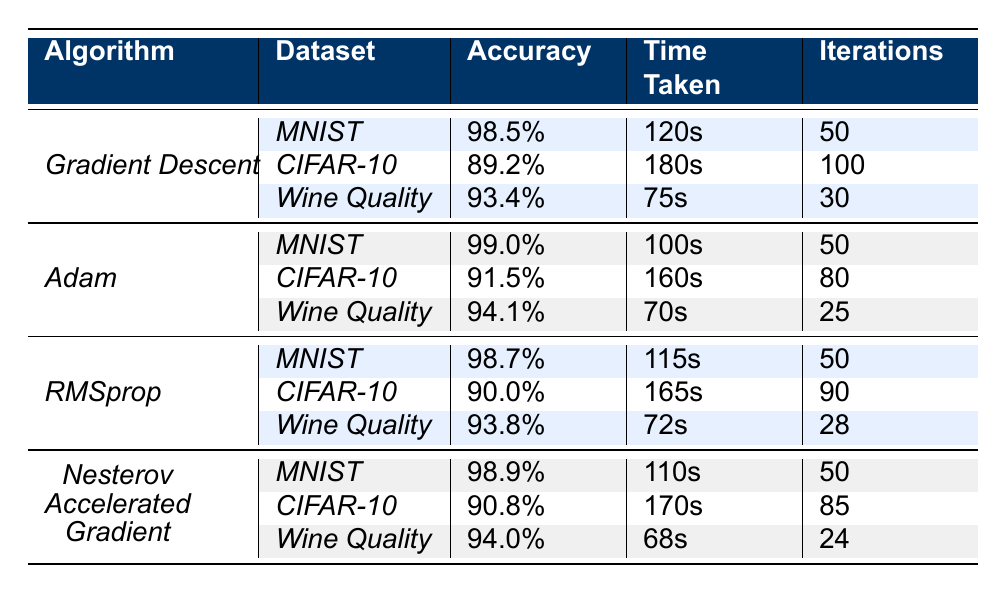What is the accuracy of the Adam algorithm on the MNIST dataset? The table shows that the accuracy of the Adam algorithm on the MNIST dataset is 99.0%.
Answer: 99.0% Which algorithm takes the least amount of time on the Wine Quality dataset? Looking at the table, the algorithm that takes the least amount of time on the Wine Quality dataset is Adam with 70 seconds.
Answer: Adam What is the difference in accuracy between Gradient Descent and RMSprop on the CIFAR-10 dataset? The accuracy of Gradient Descent on CIFAR-10 is 89.2% and RMSprop is 90.0%. The difference is 90.0% - 89.2% = 0.8%.
Answer: 0.8% Who performs better in terms of time taken on the MNIST dataset, Nesterov Accelerated Gradient or RMSprop? The time taken by Nesterov Accelerated Gradient is 110 seconds, while RMSprop takes 115 seconds. Since 110 seconds is less than 115 seconds, Nesterov Accelerated Gradient performs better.
Answer: Nesterov Accelerated Gradient What is the average accuracy for all algorithms on the Wine Quality dataset? The accuracies for Wine Quality across all algorithms are: Gradient Descent (93.4%), Adam (94.1%), RMSprop (93.8%), and Nesterov Accelerated Gradient (94.0%). We sum these values: 93.4 + 94.1 + 93.8 + 94.0 = 375.3, then divide by 4 to find the average: 375.3 / 4 = 93.825%.
Answer: 93.825% Is it true that the Nesterov Accelerated Gradient algorithm has the highest accuracy on the CIFAR-10 dataset? The accuracies for CIFAR-10 are: Gradient Descent (89.2%), Adam (91.5%), RMSprop (90.0%), and Nesterov Accelerated Gradient (90.8%). Since the highest is Adam at 91.5%, it is false that Nesterov has the highest.
Answer: No Which algorithm has the highest accuracy across all datasets? The highest accuracies are 99.0% for Adam on MNIST, 91.5% for Adam on CIFAR-10, and 94.1% for Adam on Wine Quality. The overall highest accuracy is 99.0% for Adam on MNIST.
Answer: Adam How much time does Gradient Descent take on average across all datasets? The time taken for Gradient Descent is 120s on MNIST, 180s on CIFAR-10, and 75s on Wine Quality. The total time is 120 + 180 + 75 = 375 seconds. There are 3 datasets, so the average is 375 / 3 = 125 seconds.
Answer: 125 seconds Which algorithm has the least number of iterations for the Wine Quality dataset? Looking at the iterations for Wine Quality: Gradient Descent has 30, Adam has 25, RMSprop has 28, and Nesterov Accelerated Gradient has 24. The least is 24 from Nesterov Accelerated Gradient.
Answer: Nesterov Accelerated Gradient 